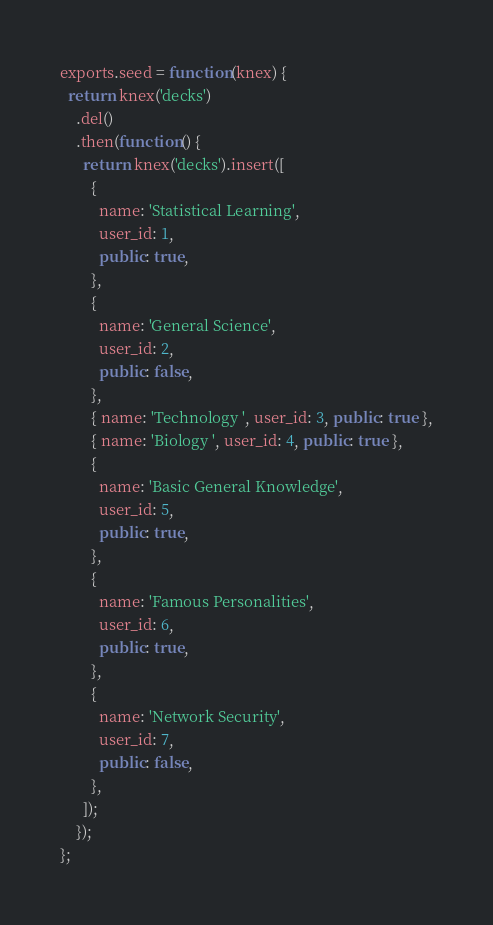<code> <loc_0><loc_0><loc_500><loc_500><_JavaScript_>exports.seed = function(knex) {
  return knex('decks')
    .del()
    .then(function() {
      return knex('decks').insert([
        {
          name: 'Statistical Learning',
          user_id: 1,
          public: true,
        },
        {
          name: 'General Science',
          user_id: 2,
          public: false,
        },
        { name: 'Technology ', user_id: 3, public: true },
        { name: 'Biology ', user_id: 4, public: true },
        {
          name: 'Basic General Knowledge',
          user_id: 5,
          public: true,
        },
        {
          name: 'Famous Personalities',
          user_id: 6,
          public: true,
        },
        {
          name: 'Network Security',
          user_id: 7,
          public: false,
        },
      ]);
    });
};
</code> 